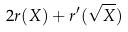Convert formula to latex. <formula><loc_0><loc_0><loc_500><loc_500>2 r ( X ) + r ^ { \prime } ( \sqrt { X } )</formula> 